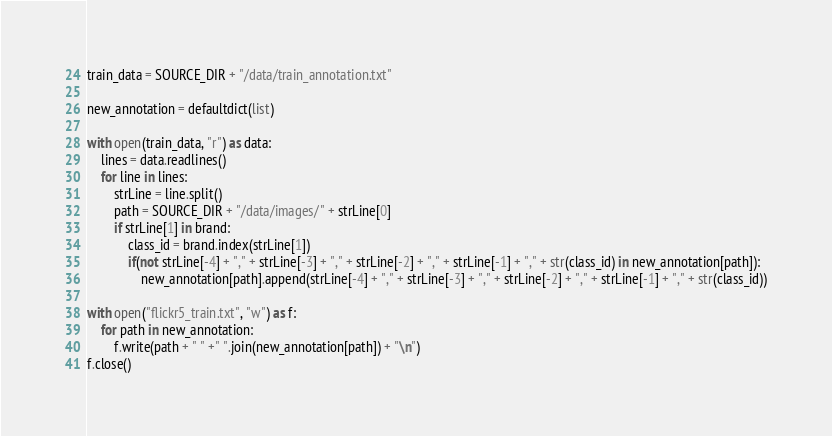<code> <loc_0><loc_0><loc_500><loc_500><_Python_>train_data = SOURCE_DIR + "/data/train_annotation.txt"

new_annotation = defaultdict(list)

with open(train_data, "r") as data:
    lines = data.readlines()
    for line in lines:
        strLine = line.split()
        path = SOURCE_DIR + "/data/images/" + strLine[0]
        if strLine[1] in brand:
            class_id = brand.index(strLine[1])
            if(not strLine[-4] + "," + strLine[-3] + "," + strLine[-2] + "," + strLine[-1] + "," + str(class_id) in new_annotation[path]):
                new_annotation[path].append(strLine[-4] + "," + strLine[-3] + "," + strLine[-2] + "," + strLine[-1] + "," + str(class_id))

with open("flickr5_train.txt", "w") as f:
    for path in new_annotation:
        f.write(path + " " +" ".join(new_annotation[path]) + "\n")
f.close()
</code> 